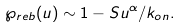<formula> <loc_0><loc_0><loc_500><loc_500>\wp _ { r e b } ( u ) \sim 1 - S u ^ { \alpha } / k _ { o n } .</formula> 